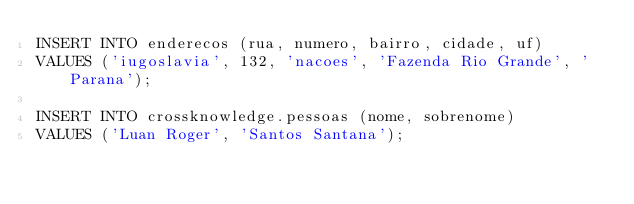Convert code to text. <code><loc_0><loc_0><loc_500><loc_500><_SQL_>INSERT INTO enderecos (rua, numero, bairro, cidade, uf)
VALUES ('iugoslavia', 132, 'nacoes', 'Fazenda Rio Grande', 'Parana');

INSERT INTO crossknowledge.pessoas (nome, sobrenome)
VALUES ('Luan Roger', 'Santos Santana');</code> 